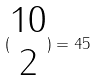Convert formula to latex. <formula><loc_0><loc_0><loc_500><loc_500>( \begin{matrix} 1 0 \\ 2 \end{matrix} ) = 4 5</formula> 